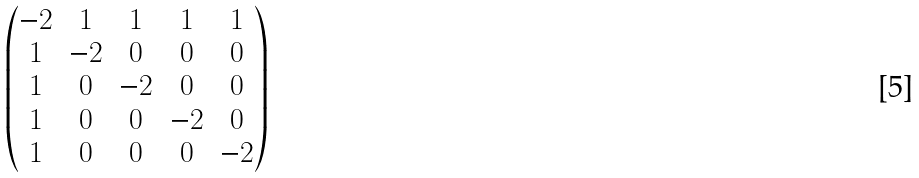<formula> <loc_0><loc_0><loc_500><loc_500>\begin{pmatrix} - 2 & 1 & 1 & 1 & 1 \\ 1 & - 2 & 0 & 0 & 0 \\ 1 & 0 & - 2 & 0 & 0 \\ 1 & 0 & 0 & - 2 & 0 \\ 1 & 0 & 0 & 0 & - 2 \end{pmatrix}</formula> 